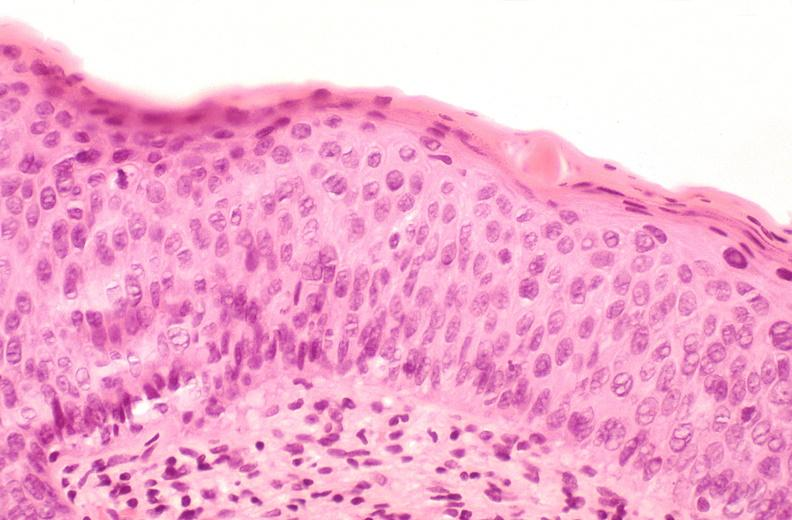where is this from?
Answer the question using a single word or phrase. Female reproductive system 